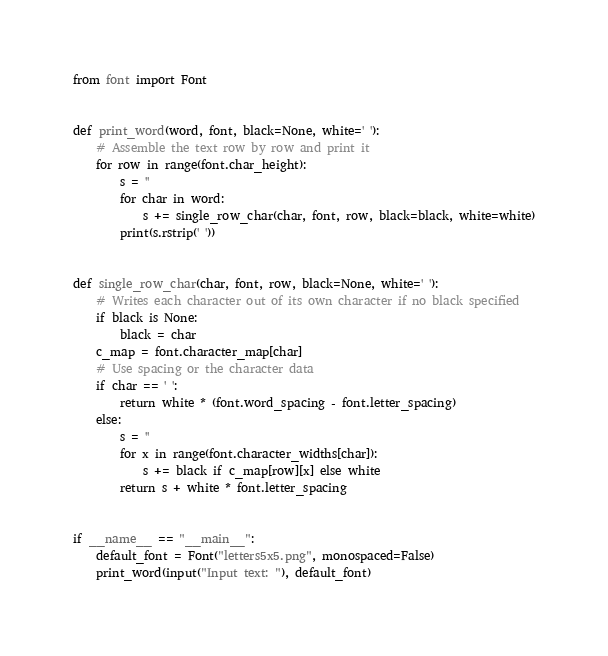<code> <loc_0><loc_0><loc_500><loc_500><_Python_>from font import Font


def print_word(word, font, black=None, white=' '):
    # Assemble the text row by row and print it
    for row in range(font.char_height):
        s = ''
        for char in word:
            s += single_row_char(char, font, row, black=black, white=white)
        print(s.rstrip(' '))


def single_row_char(char, font, row, black=None, white=' '):
    # Writes each character out of its own character if no black specified
    if black is None:
        black = char
    c_map = font.character_map[char]
    # Use spacing or the character data
    if char == ' ':
        return white * (font.word_spacing - font.letter_spacing)
    else:
        s = ''
        for x in range(font.character_widths[char]):
            s += black if c_map[row][x] else white
        return s + white * font.letter_spacing


if __name__ == "__main__":
    default_font = Font("letters5x5.png", monospaced=False)
    print_word(input("Input text: "), default_font)
</code> 